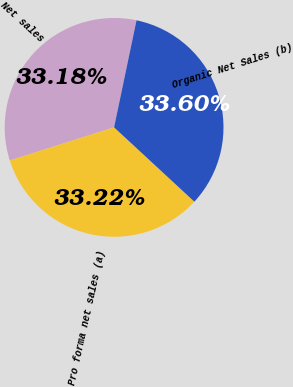<chart> <loc_0><loc_0><loc_500><loc_500><pie_chart><fcel>Net sales<fcel>Pro forma net sales (a)<fcel>Organic Net Sales (b)<nl><fcel>33.18%<fcel>33.22%<fcel>33.6%<nl></chart> 